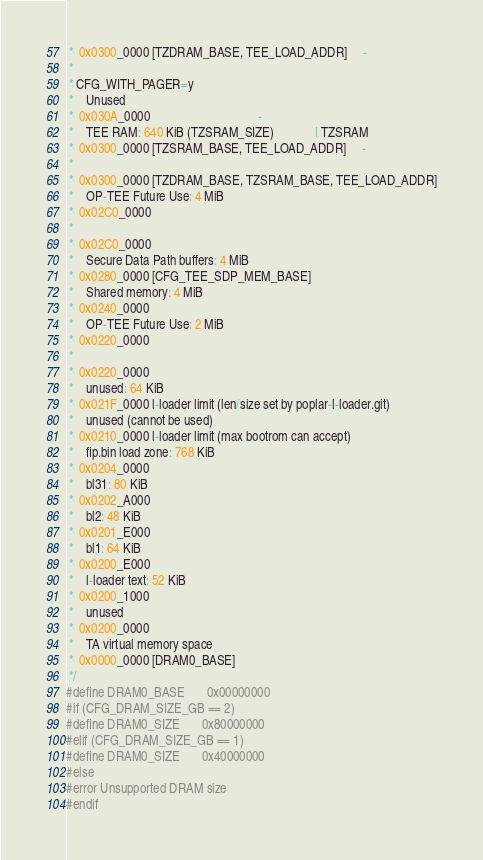<code> <loc_0><loc_0><loc_500><loc_500><_C_> *  0x0300_0000 [TZDRAM_BASE, TEE_LOAD_ADDR]     -
 *
 * CFG_WITH_PAGER=y
 *    Unused
 *  0x030A_0000                                  -
 *    TEE RAM: 640 KiB (TZSRAM_SIZE)             | TZSRAM
 *  0x0300_0000 [TZSRAM_BASE, TEE_LOAD_ADDR]     -
 *
 *  0x0300_0000 [TZDRAM_BASE, TZSRAM_BASE, TEE_LOAD_ADDR]
 *    OP-TEE Future Use: 4 MiB
 *  0x02C0_0000
 *
 *  0x02C0_0000
 *    Secure Data Path buffers: 4 MiB
 *  0x0280_0000 [CFG_TEE_SDP_MEM_BASE]
 *    Shared memory: 4 MiB
 *  0x0240_0000
 *    OP-TEE Future Use: 2 MiB
 *  0x0220_0000
 *
 *  0x0220_0000
 *    unused: 64 KiB
 *  0x021F_0000 l-loader limit (len/size set by poplar-l-loader.git)
 *    unused (cannot be used)
 *  0x0210_0000 l-loader limit (max bootrom can accept)
 *    fip.bin load zone: 768 KiB
 *  0x0204_0000
 *    bl31: 80 KiB
 *  0x0202_A000
 *    bl2: 48 KiB
 *  0x0201_E000
 *    bl1: 64 KiB
 *  0x0200_E000
 *    l-loader text: 52 KiB
 *  0x0200_1000
 *    unused
 *  0x0200_0000
 *    TA virtual memory space
 *  0x0000_0000 [DRAM0_BASE]
 */
#define DRAM0_BASE		0x00000000
#if (CFG_DRAM_SIZE_GB == 2)
#define DRAM0_SIZE		0x80000000
#elif (CFG_DRAM_SIZE_GB == 1)
#define DRAM0_SIZE		0x40000000
#else
#error Unsupported DRAM size
#endif
</code> 